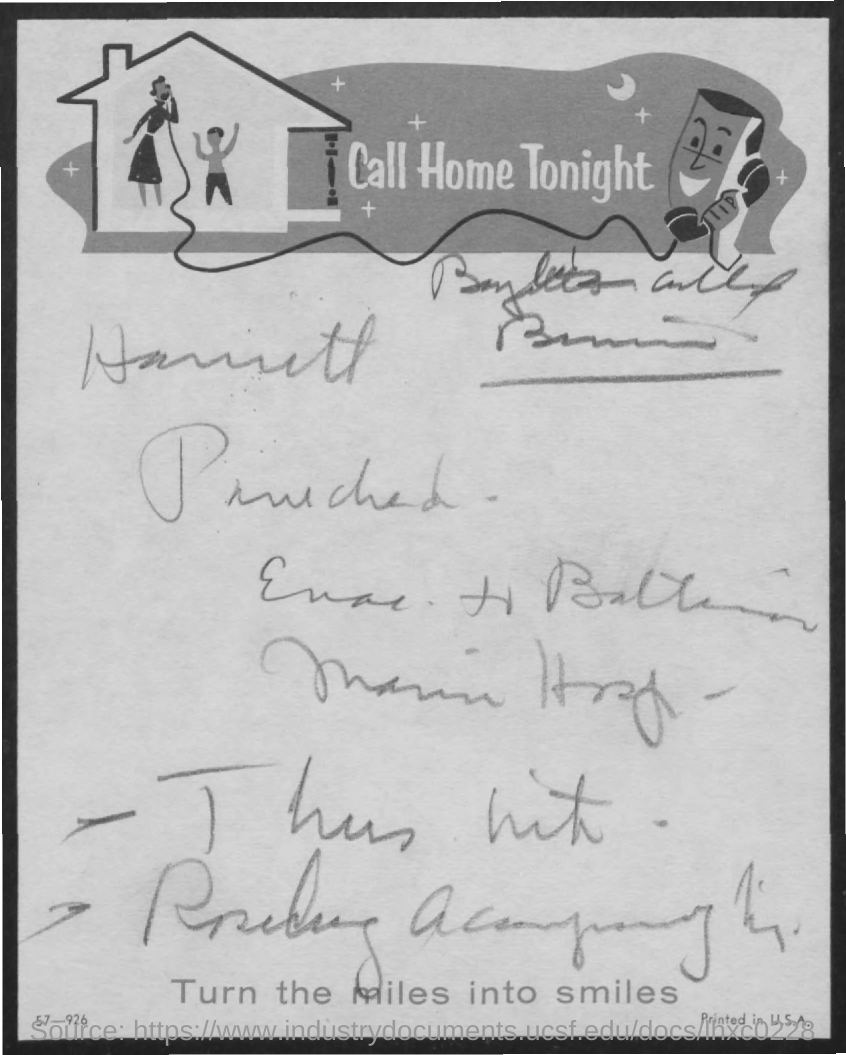What is the title at the bottom of the document?
Give a very brief answer. Turn the miles into smiles. 